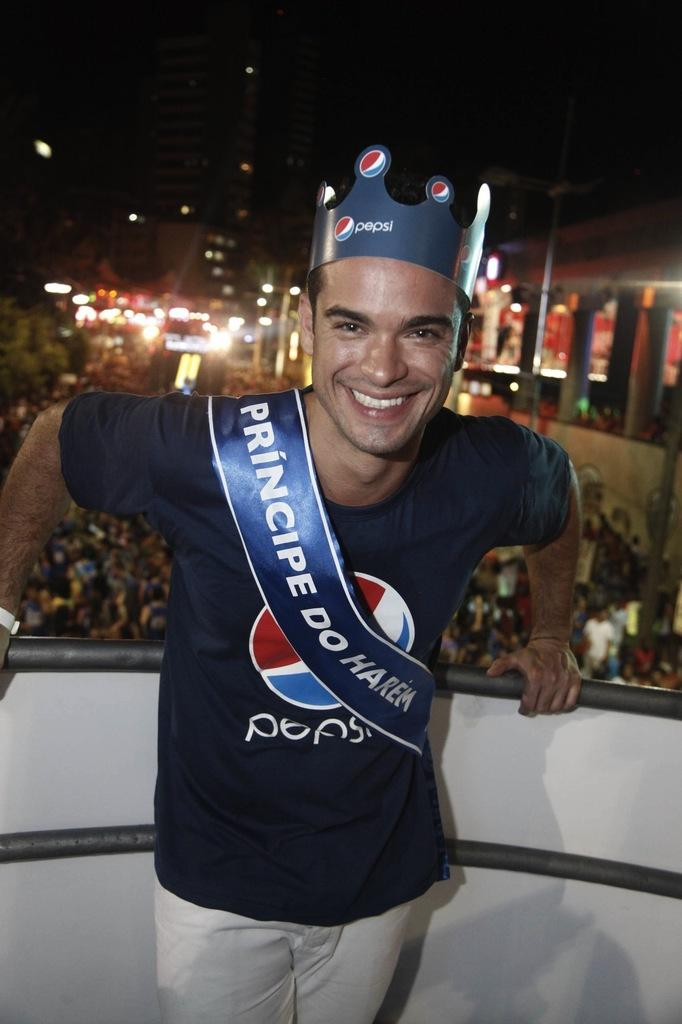<image>
Create a compact narrative representing the image presented. A guy with a pepsi shirt and crown wearing a sash that says principe do harem. 